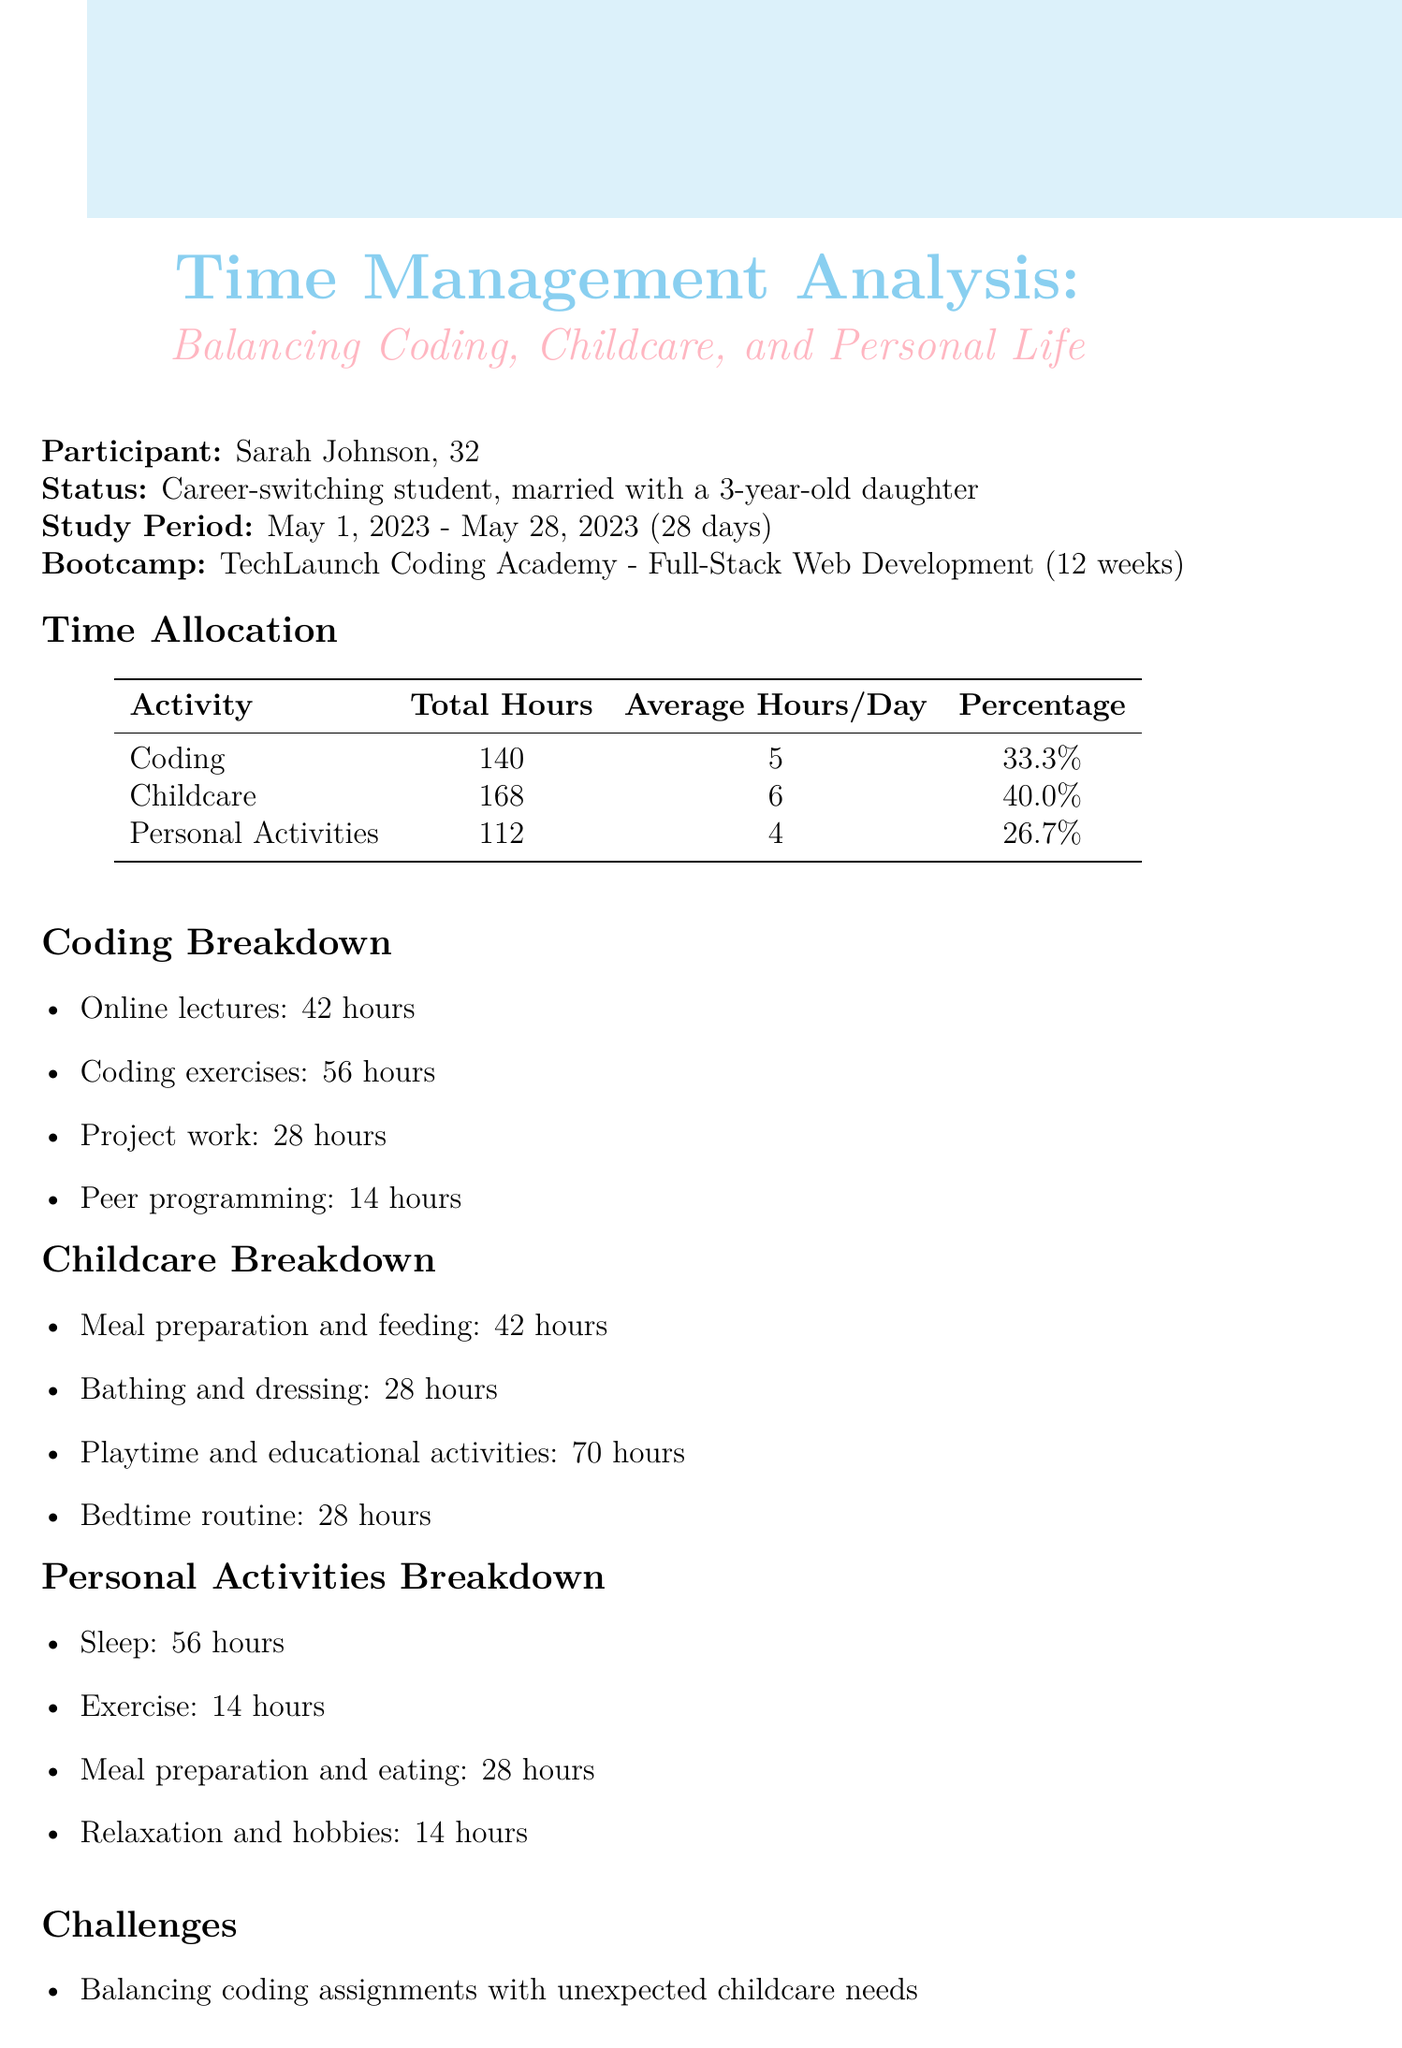what is the name of the coding bootcamp? The name of the coding bootcamp is mentioned in the document, which is TechLaunch Coding Academy.
Answer: TechLaunch Coding Academy what is the total number of hours spent on childcare? The document provides a breakdown of time allocation, stating the total hours spent on childcare is 168.
Answer: 168 how many hours were allocated for sleep? The document specifies the hours spent on sleep as part of personal activities, which is 56 hours.
Answer: 56 what percentage of total time was spent on coding? The percentage of total time spent on coding is detailed in the time allocation, which is 33.3 percent.
Answer: 33.3% what are the average hours spent on personal activities per day? The average hours spent on personal activities per day can be found in the time allocation section, which is 4.
Answer: 4 which challenge involves coordinating schedules? The document lists challenges, and one mentions the need for coordinating schedules with a spouse for childcare coverage.
Answer: Coordinating schedules with spouse for childcare coverage name one productivity tool mentioned in the report. The document lists several productivity tools; one of them is Trello.
Answer: Trello what future plan includes working in web development? The document outlines future plans, mentioning an intent to explore part-time job opportunities in web development.
Answer: Explore part-time job opportunities in web development how much of the bootcamp curriculum has been completed? The outcomes section of the document states that 35 percent of the bootcamp curriculum has been completed.
Answer: 35% 